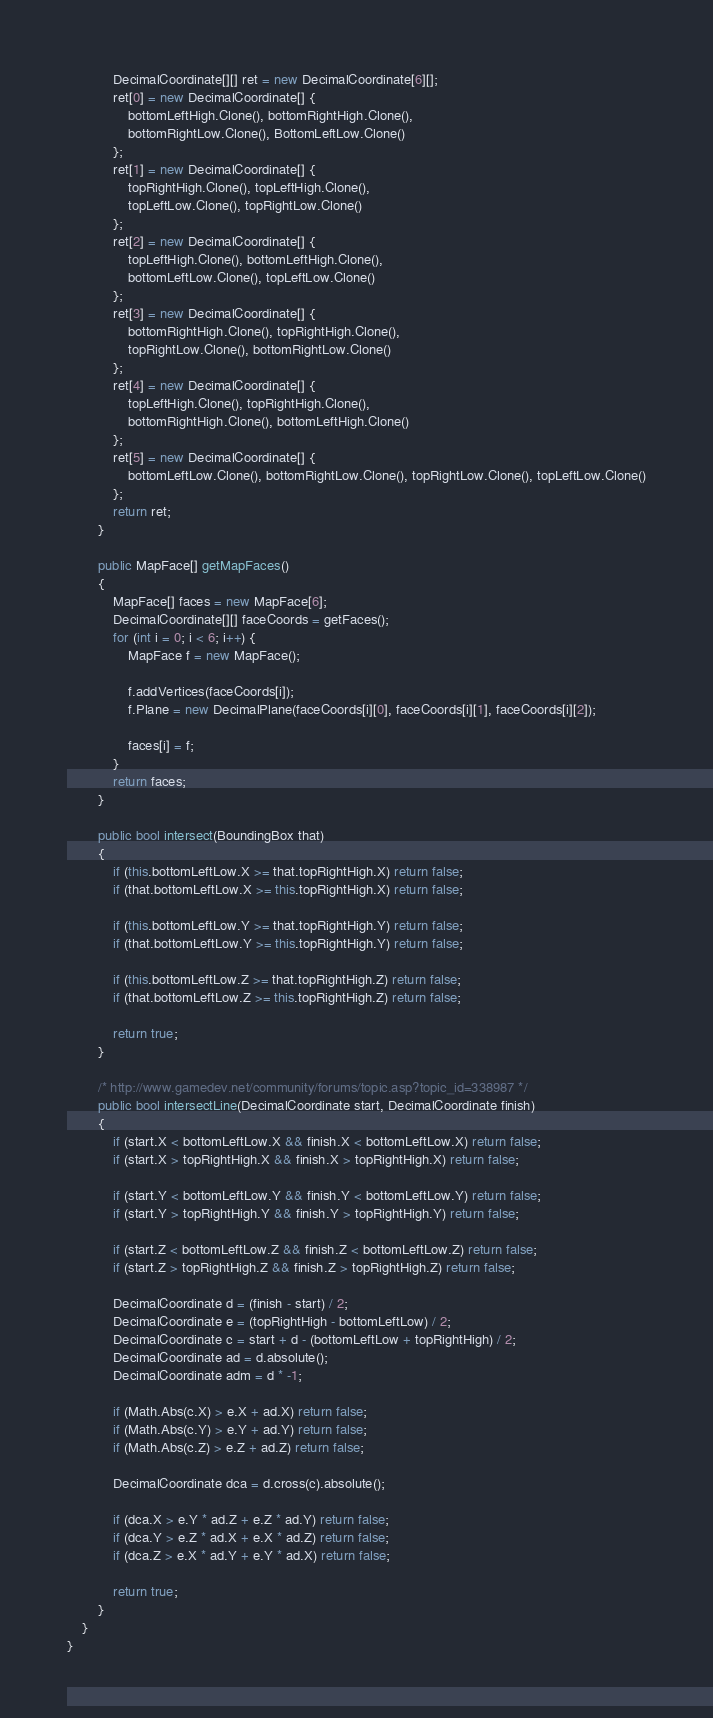Convert code to text. <code><loc_0><loc_0><loc_500><loc_500><_C#_>			DecimalCoordinate[][] ret = new DecimalCoordinate[6][];
			ret[0] = new DecimalCoordinate[] {
				bottomLeftHigh.Clone(), bottomRightHigh.Clone(),
				bottomRightLow.Clone(), BottomLeftLow.Clone()
			};
			ret[1] = new DecimalCoordinate[] {
				topRightHigh.Clone(), topLeftHigh.Clone(),
				topLeftLow.Clone(), topRightLow.Clone()
			};
			ret[2] = new DecimalCoordinate[] {
				topLeftHigh.Clone(), bottomLeftHigh.Clone(),
				bottomLeftLow.Clone(), topLeftLow.Clone()
			};
			ret[3] = new DecimalCoordinate[] {
				bottomRightHigh.Clone(), topRightHigh.Clone(),
				topRightLow.Clone(), bottomRightLow.Clone()
			};
			ret[4] = new DecimalCoordinate[] {
				topLeftHigh.Clone(), topRightHigh.Clone(),
				bottomRightHigh.Clone(), bottomLeftHigh.Clone()
			};
			ret[5] = new DecimalCoordinate[] {
				bottomLeftLow.Clone(), bottomRightLow.Clone(), topRightLow.Clone(), topLeftLow.Clone()
			};
			return ret;
		}
		
		public MapFace[] getMapFaces()
		{
			MapFace[] faces = new MapFace[6];
			DecimalCoordinate[][] faceCoords = getFaces();
			for (int i = 0; i < 6; i++) {
				MapFace f = new MapFace();
				
				f.addVertices(faceCoords[i]);
				f.Plane = new DecimalPlane(faceCoords[i][0], faceCoords[i][1], faceCoords[i][2]);
				
				faces[i] = f;
			}
			return faces;
		}
		
		public bool intersect(BoundingBox that)
		{
			if (this.bottomLeftLow.X >= that.topRightHigh.X) return false;
			if (that.bottomLeftLow.X >= this.topRightHigh.X) return false;
			
			if (this.bottomLeftLow.Y >= that.topRightHigh.Y) return false;
			if (that.bottomLeftLow.Y >= this.topRightHigh.Y) return false;
			
			if (this.bottomLeftLow.Z >= that.topRightHigh.Z) return false;
			if (that.bottomLeftLow.Z >= this.topRightHigh.Z) return false;
			
			return true;
		}
		
		/* http://www.gamedev.net/community/forums/topic.asp?topic_id=338987 */
		public bool intersectLine(DecimalCoordinate start, DecimalCoordinate finish)
		{
			if (start.X < bottomLeftLow.X && finish.X < bottomLeftLow.X) return false;
			if (start.X > topRightHigh.X && finish.X > topRightHigh.X) return false;
			
			if (start.Y < bottomLeftLow.Y && finish.Y < bottomLeftLow.Y) return false;
			if (start.Y > topRightHigh.Y && finish.Y > topRightHigh.Y) return false;
			
			if (start.Z < bottomLeftLow.Z && finish.Z < bottomLeftLow.Z) return false;
			if (start.Z > topRightHigh.Z && finish.Z > topRightHigh.Z) return false;
			
			DecimalCoordinate d = (finish - start) / 2;
			DecimalCoordinate e = (topRightHigh - bottomLeftLow) / 2;
			DecimalCoordinate c = start + d - (bottomLeftLow + topRightHigh) / 2;
			DecimalCoordinate ad = d.absolute();
			DecimalCoordinate adm = d * -1;
			
			if (Math.Abs(c.X) > e.X + ad.X) return false;
			if (Math.Abs(c.Y) > e.Y + ad.Y) return false;
			if (Math.Abs(c.Z) > e.Z + ad.Z) return false;
			
			DecimalCoordinate dca = d.cross(c).absolute();
			
			if (dca.X > e.Y * ad.Z + e.Z * ad.Y) return false;
			if (dca.Y > e.Z * ad.X + e.X * ad.Z) return false;
			if (dca.Z > e.X * ad.Y + e.Y * ad.X) return false;
			
			return true;
		}
	}
}
</code> 